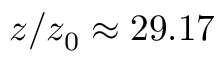<formula> <loc_0><loc_0><loc_500><loc_500>z / z _ { 0 } \approx 2 9 . 1 7</formula> 